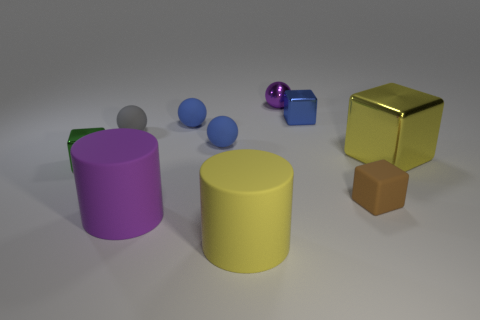There is a small thing that is both in front of the tiny blue metallic cube and on the right side of the shiny sphere; what is its shape? The shape of the object that is positioned in front of the tiny blue metallic cube and to the right of the shiny sphere is spherical. It appears to be a small ball, reflecting the environment with its glossy texture. 